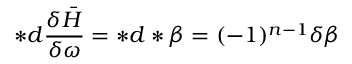<formula> <loc_0><loc_0><loc_500><loc_500>\ast d \frac { \delta \bar { H } } { \delta \omega } = \ast d \ast \beta = ( - 1 ) ^ { n - 1 } \delta \beta</formula> 